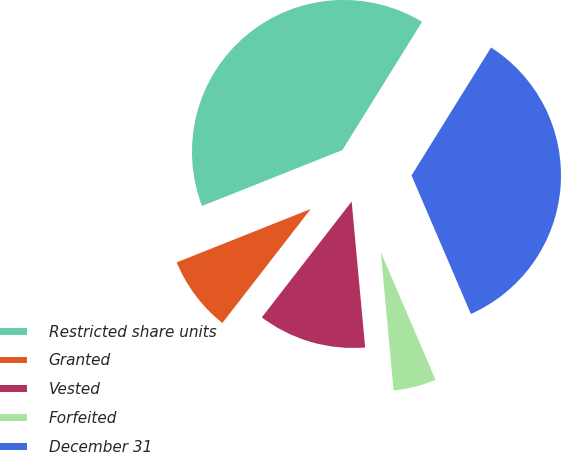Convert chart to OTSL. <chart><loc_0><loc_0><loc_500><loc_500><pie_chart><fcel>Restricted share units<fcel>Granted<fcel>Vested<fcel>Forfeited<fcel>December 31<nl><fcel>39.88%<fcel>8.47%<fcel>11.96%<fcel>4.98%<fcel>34.7%<nl></chart> 